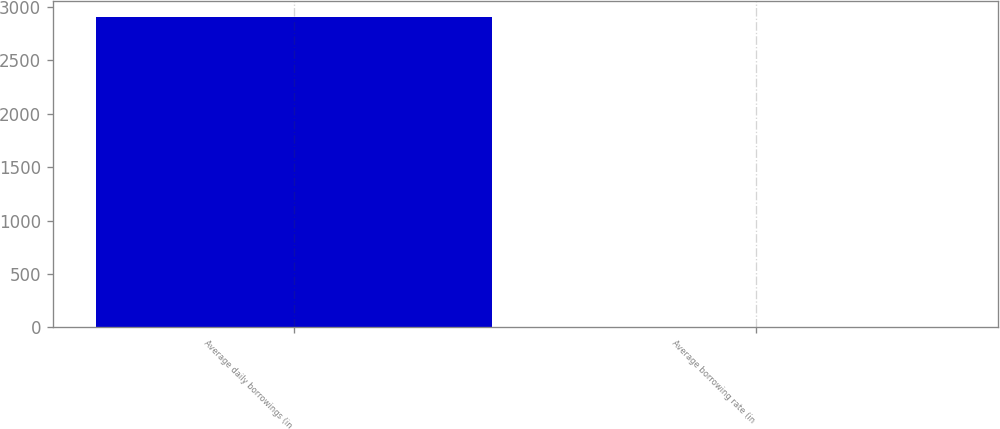Convert chart to OTSL. <chart><loc_0><loc_0><loc_500><loc_500><bar_chart><fcel>Average daily borrowings (in<fcel>Average borrowing rate (in<nl><fcel>2909<fcel>5.9<nl></chart> 